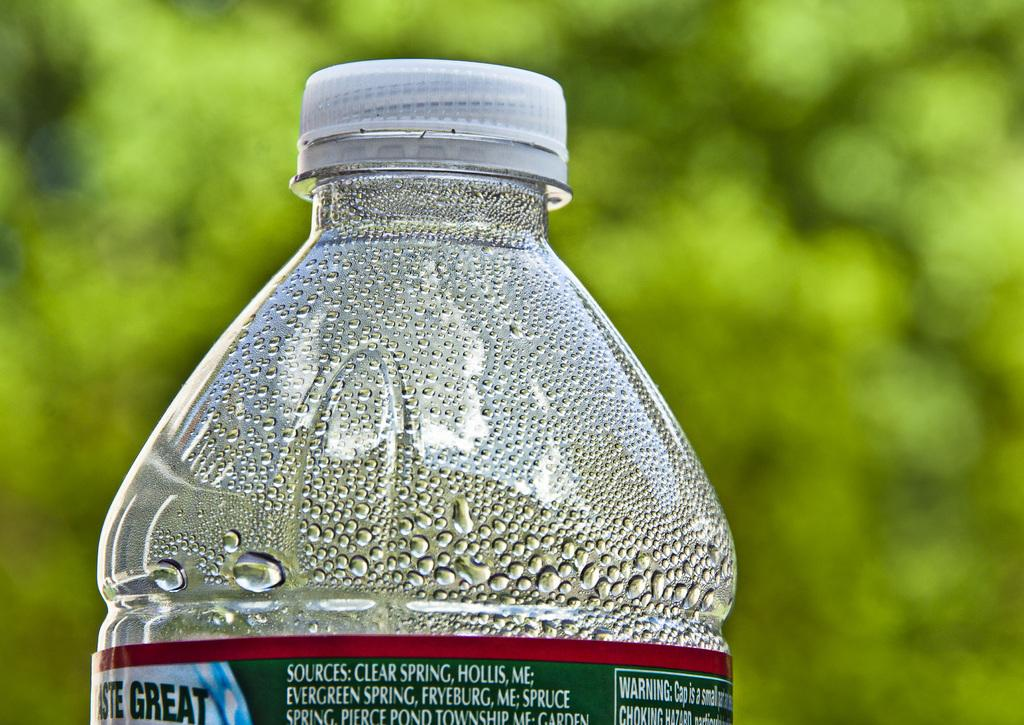What object is present in the image with a label? There is a bottle in the image with a red and green label. What color is the cap of the bottle? The bottle has a white cap. What can be seen on the surface of the bottle? There are water drops on the bottle. How many cats are sitting on the square table in the image? There are no cats or square table present in the image. 